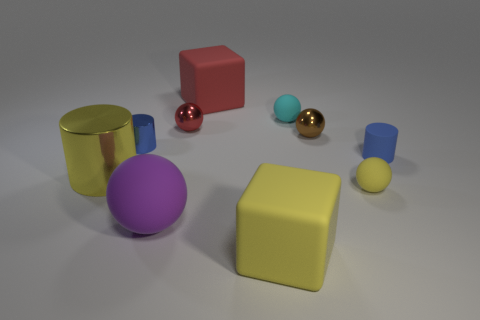Subtract all purple spheres. How many spheres are left? 4 Subtract all tiny cyan spheres. How many spheres are left? 4 Subtract all brown balls. Subtract all yellow blocks. How many balls are left? 4 Subtract all blocks. How many objects are left? 8 Add 6 small blue rubber objects. How many small blue rubber objects exist? 7 Subtract 0 cyan cylinders. How many objects are left? 10 Subtract all blue metallic cylinders. Subtract all small blue metal cylinders. How many objects are left? 8 Add 5 tiny red spheres. How many tiny red spheres are left? 6 